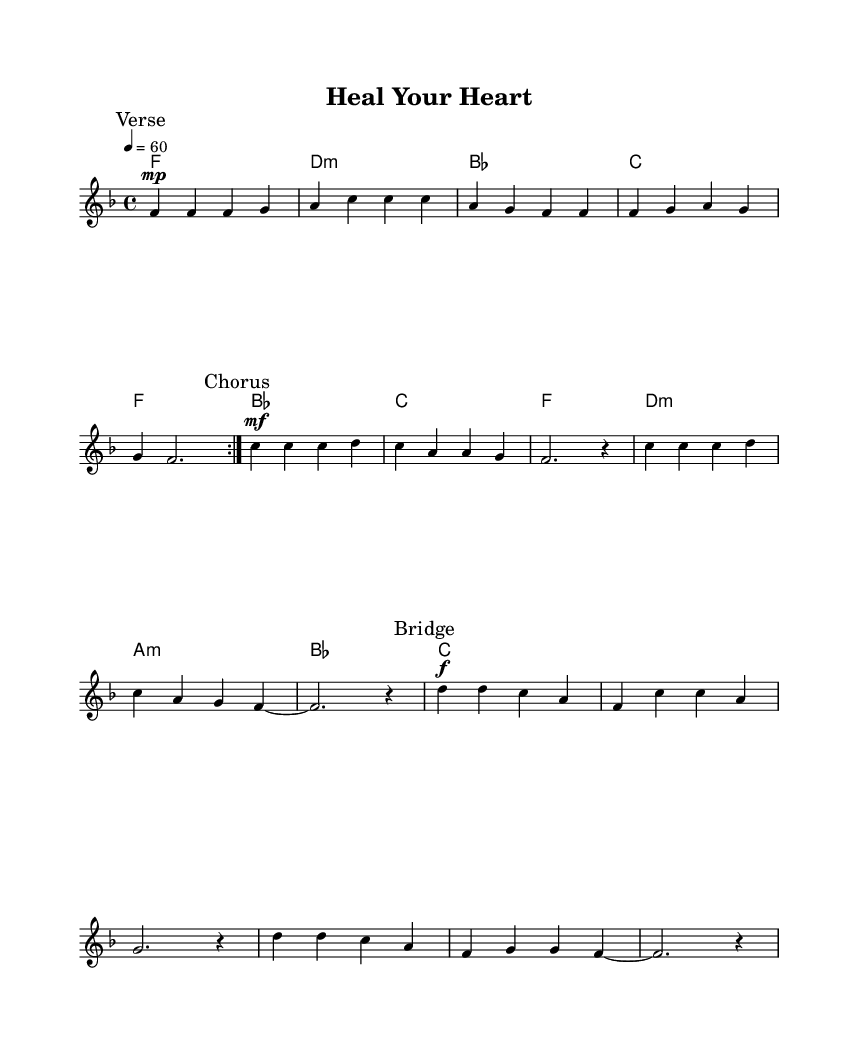What is the key signature of this music? The key signature is F major, which has one flat (B flat).
Answer: F major What is the time signature of this music? The time signature is 4/4, which means there are four beats per measure and a quarter note receives one beat.
Answer: 4/4 What is the tempo marking in this music? The tempo marking indicates that the piece should be played at 60 beats per minute.
Answer: 60 How many measures are in the verse section? The verse section consists of 8 measures, as indicated by the repeat marking showing that it plays twice.
Answer: 8 In which section does the dynamic marking "f" first appear? The dynamic marking "f" first appears in the bridge section, signaling a louder volume than the previous sections.
Answer: Bridge What is the last chord of the bridge section? The last chord of the bridge section is C major, indicated at the end of the chord progression shown.
Answer: C 